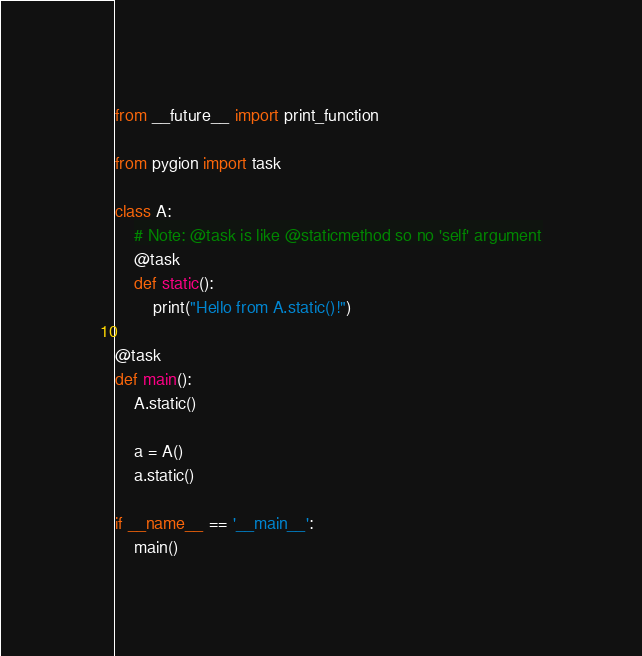Convert code to text. <code><loc_0><loc_0><loc_500><loc_500><_Python_>
from __future__ import print_function

from pygion import task

class A:
    # Note: @task is like @staticmethod so no 'self' argument
    @task
    def static():
        print("Hello from A.static()!")

@task
def main():
    A.static()

    a = A()
    a.static()

if __name__ == '__main__':
    main()
</code> 